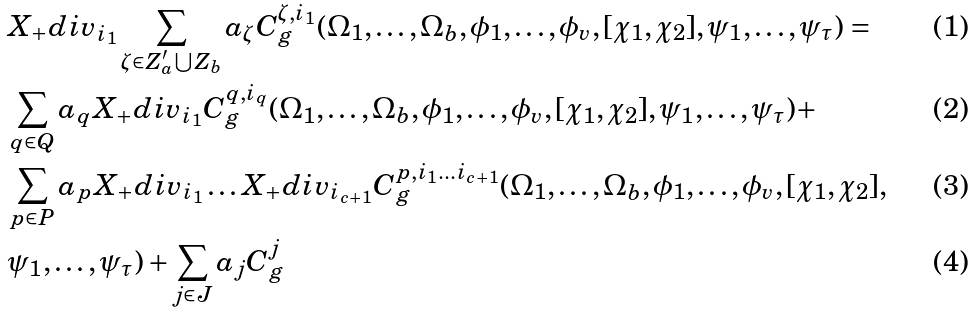<formula> <loc_0><loc_0><loc_500><loc_500>& X _ { + } d i v _ { i _ { 1 } } \sum _ { \zeta \in Z ^ { \prime } _ { a } \bigcup Z _ { b } } a _ { \zeta } C ^ { \zeta , i _ { 1 } } _ { g } ( \Omega _ { 1 } , \dots , \Omega _ { b } , \phi _ { 1 } , \dots , \phi _ { v } , [ \chi _ { 1 } , \chi _ { 2 } ] , \psi _ { 1 } , \dots , \psi _ { \tau } ) = \\ & \sum _ { q \in Q } a _ { q } X _ { + } d i v _ { i _ { 1 } } C ^ { q , i _ { q } } _ { g } ( \Omega _ { 1 } , \dots , \Omega _ { b } , \phi _ { 1 } , \dots , \phi _ { v } , [ \chi _ { 1 } , \chi _ { 2 } ] , \psi _ { 1 } , \dots , \psi _ { \tau } ) + \\ & \sum _ { p \in P } a _ { p } X _ { + } d i v _ { i _ { 1 } } \dots X _ { + } d i v _ { i _ { c + 1 } } C ^ { p , i _ { 1 } \dots i _ { c + 1 } } _ { g } ( \Omega _ { 1 } , \dots , \Omega _ { b } , \phi _ { 1 } , \dots , \phi _ { v } , [ \chi _ { 1 } , \chi _ { 2 } ] , \\ & \psi _ { 1 } , \dots , \psi _ { \tau } ) + \sum _ { j \in J } a _ { j } C ^ { j } _ { g }</formula> 